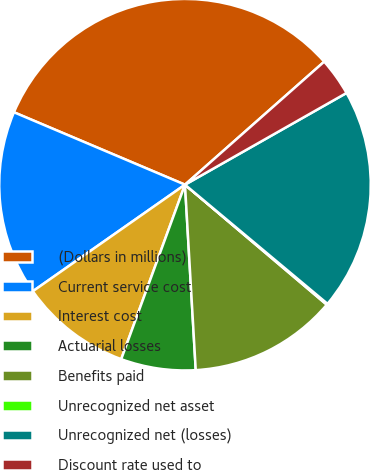<chart> <loc_0><loc_0><loc_500><loc_500><pie_chart><fcel>(Dollars in millions)<fcel>Current service cost<fcel>Interest cost<fcel>Actuarial losses<fcel>Benefits paid<fcel>Unrecognized net asset<fcel>Unrecognized net (losses)<fcel>Discount rate used to<nl><fcel>32.11%<fcel>16.1%<fcel>9.7%<fcel>6.5%<fcel>12.9%<fcel>0.1%<fcel>19.3%<fcel>3.3%<nl></chart> 